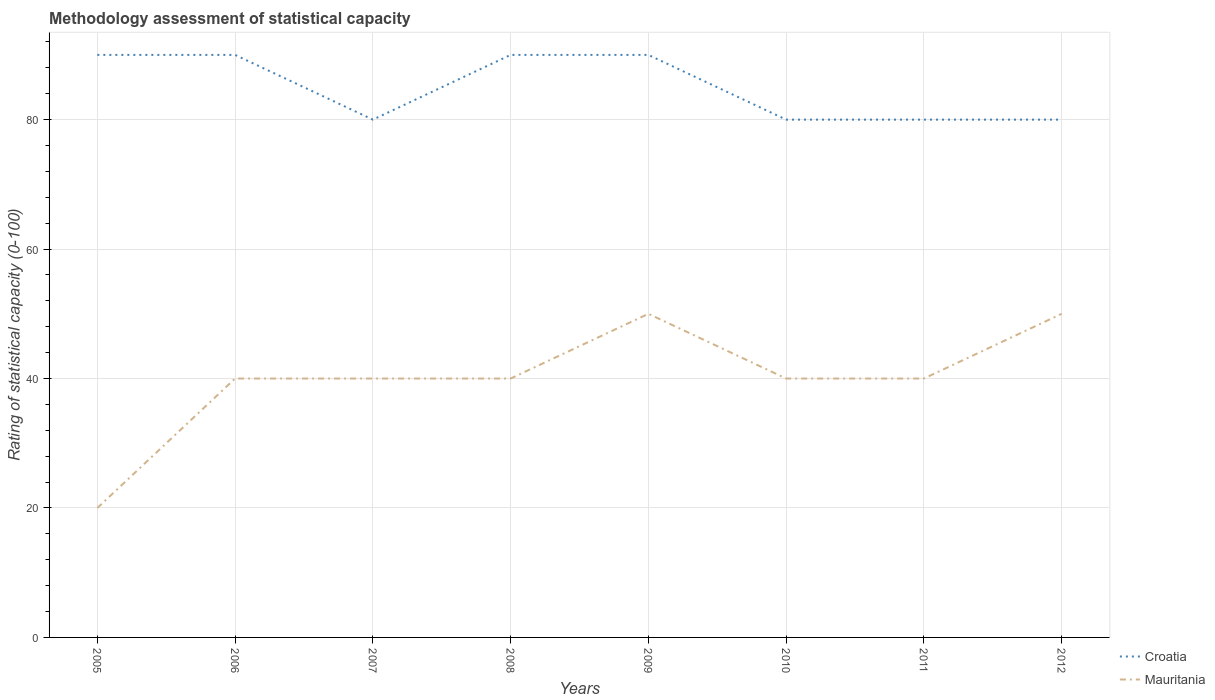How many different coloured lines are there?
Your answer should be compact. 2. Is the number of lines equal to the number of legend labels?
Ensure brevity in your answer.  Yes. Across all years, what is the maximum rating of statistical capacity in Croatia?
Provide a short and direct response. 80. In which year was the rating of statistical capacity in Croatia maximum?
Give a very brief answer. 2007. What is the total rating of statistical capacity in Mauritania in the graph?
Give a very brief answer. 0. What is the difference between the highest and the second highest rating of statistical capacity in Croatia?
Ensure brevity in your answer.  10. How many years are there in the graph?
Provide a short and direct response. 8. What is the difference between two consecutive major ticks on the Y-axis?
Your answer should be very brief. 20. Are the values on the major ticks of Y-axis written in scientific E-notation?
Provide a succinct answer. No. Where does the legend appear in the graph?
Ensure brevity in your answer.  Bottom right. How are the legend labels stacked?
Your answer should be very brief. Vertical. What is the title of the graph?
Provide a succinct answer. Methodology assessment of statistical capacity. Does "Panama" appear as one of the legend labels in the graph?
Your response must be concise. No. What is the label or title of the Y-axis?
Offer a very short reply. Rating of statistical capacity (0-100). What is the Rating of statistical capacity (0-100) of Croatia in 2005?
Offer a very short reply. 90. What is the Rating of statistical capacity (0-100) of Croatia in 2008?
Offer a terse response. 90. What is the Rating of statistical capacity (0-100) of Mauritania in 2008?
Ensure brevity in your answer.  40. What is the Rating of statistical capacity (0-100) of Croatia in 2010?
Ensure brevity in your answer.  80. What is the Rating of statistical capacity (0-100) of Mauritania in 2010?
Provide a short and direct response. 40. What is the Rating of statistical capacity (0-100) in Mauritania in 2011?
Give a very brief answer. 40. What is the Rating of statistical capacity (0-100) of Croatia in 2012?
Provide a succinct answer. 80. What is the Rating of statistical capacity (0-100) of Mauritania in 2012?
Give a very brief answer. 50. Across all years, what is the maximum Rating of statistical capacity (0-100) of Mauritania?
Provide a short and direct response. 50. Across all years, what is the minimum Rating of statistical capacity (0-100) in Croatia?
Keep it short and to the point. 80. Across all years, what is the minimum Rating of statistical capacity (0-100) of Mauritania?
Your response must be concise. 20. What is the total Rating of statistical capacity (0-100) of Croatia in the graph?
Ensure brevity in your answer.  680. What is the total Rating of statistical capacity (0-100) of Mauritania in the graph?
Make the answer very short. 320. What is the difference between the Rating of statistical capacity (0-100) in Mauritania in 2005 and that in 2006?
Keep it short and to the point. -20. What is the difference between the Rating of statistical capacity (0-100) in Croatia in 2005 and that in 2008?
Offer a terse response. 0. What is the difference between the Rating of statistical capacity (0-100) of Mauritania in 2005 and that in 2010?
Make the answer very short. -20. What is the difference between the Rating of statistical capacity (0-100) of Croatia in 2005 and that in 2011?
Your response must be concise. 10. What is the difference between the Rating of statistical capacity (0-100) of Mauritania in 2005 and that in 2011?
Provide a short and direct response. -20. What is the difference between the Rating of statistical capacity (0-100) in Mauritania in 2005 and that in 2012?
Offer a very short reply. -30. What is the difference between the Rating of statistical capacity (0-100) in Croatia in 2006 and that in 2009?
Provide a short and direct response. 0. What is the difference between the Rating of statistical capacity (0-100) of Croatia in 2006 and that in 2010?
Your response must be concise. 10. What is the difference between the Rating of statistical capacity (0-100) of Croatia in 2006 and that in 2011?
Give a very brief answer. 10. What is the difference between the Rating of statistical capacity (0-100) of Croatia in 2007 and that in 2010?
Your answer should be very brief. 0. What is the difference between the Rating of statistical capacity (0-100) in Mauritania in 2007 and that in 2010?
Offer a terse response. 0. What is the difference between the Rating of statistical capacity (0-100) of Mauritania in 2007 and that in 2011?
Keep it short and to the point. 0. What is the difference between the Rating of statistical capacity (0-100) of Croatia in 2007 and that in 2012?
Give a very brief answer. 0. What is the difference between the Rating of statistical capacity (0-100) of Croatia in 2008 and that in 2009?
Offer a very short reply. 0. What is the difference between the Rating of statistical capacity (0-100) of Mauritania in 2008 and that in 2009?
Keep it short and to the point. -10. What is the difference between the Rating of statistical capacity (0-100) of Croatia in 2008 and that in 2010?
Your response must be concise. 10. What is the difference between the Rating of statistical capacity (0-100) in Mauritania in 2008 and that in 2010?
Provide a short and direct response. 0. What is the difference between the Rating of statistical capacity (0-100) of Croatia in 2009 and that in 2010?
Offer a very short reply. 10. What is the difference between the Rating of statistical capacity (0-100) in Mauritania in 2009 and that in 2011?
Provide a short and direct response. 10. What is the difference between the Rating of statistical capacity (0-100) of Croatia in 2009 and that in 2012?
Ensure brevity in your answer.  10. What is the difference between the Rating of statistical capacity (0-100) in Mauritania in 2009 and that in 2012?
Give a very brief answer. 0. What is the difference between the Rating of statistical capacity (0-100) in Croatia in 2010 and that in 2011?
Your answer should be very brief. 0. What is the difference between the Rating of statistical capacity (0-100) in Mauritania in 2010 and that in 2011?
Give a very brief answer. 0. What is the difference between the Rating of statistical capacity (0-100) in Croatia in 2010 and that in 2012?
Your answer should be compact. 0. What is the difference between the Rating of statistical capacity (0-100) of Croatia in 2005 and the Rating of statistical capacity (0-100) of Mauritania in 2011?
Offer a very short reply. 50. What is the difference between the Rating of statistical capacity (0-100) of Croatia in 2006 and the Rating of statistical capacity (0-100) of Mauritania in 2007?
Offer a very short reply. 50. What is the difference between the Rating of statistical capacity (0-100) in Croatia in 2006 and the Rating of statistical capacity (0-100) in Mauritania in 2008?
Ensure brevity in your answer.  50. What is the difference between the Rating of statistical capacity (0-100) of Croatia in 2008 and the Rating of statistical capacity (0-100) of Mauritania in 2009?
Your response must be concise. 40. What is the difference between the Rating of statistical capacity (0-100) in Croatia in 2008 and the Rating of statistical capacity (0-100) in Mauritania in 2011?
Provide a short and direct response. 50. What is the difference between the Rating of statistical capacity (0-100) of Croatia in 2008 and the Rating of statistical capacity (0-100) of Mauritania in 2012?
Your response must be concise. 40. What is the difference between the Rating of statistical capacity (0-100) in Croatia in 2009 and the Rating of statistical capacity (0-100) in Mauritania in 2010?
Ensure brevity in your answer.  50. What is the difference between the Rating of statistical capacity (0-100) of Croatia in 2010 and the Rating of statistical capacity (0-100) of Mauritania in 2012?
Ensure brevity in your answer.  30. What is the difference between the Rating of statistical capacity (0-100) of Croatia in 2011 and the Rating of statistical capacity (0-100) of Mauritania in 2012?
Offer a terse response. 30. In the year 2005, what is the difference between the Rating of statistical capacity (0-100) in Croatia and Rating of statistical capacity (0-100) in Mauritania?
Give a very brief answer. 70. In the year 2007, what is the difference between the Rating of statistical capacity (0-100) of Croatia and Rating of statistical capacity (0-100) of Mauritania?
Your answer should be compact. 40. In the year 2010, what is the difference between the Rating of statistical capacity (0-100) in Croatia and Rating of statistical capacity (0-100) in Mauritania?
Offer a terse response. 40. In the year 2011, what is the difference between the Rating of statistical capacity (0-100) in Croatia and Rating of statistical capacity (0-100) in Mauritania?
Your answer should be compact. 40. In the year 2012, what is the difference between the Rating of statistical capacity (0-100) of Croatia and Rating of statistical capacity (0-100) of Mauritania?
Provide a succinct answer. 30. What is the ratio of the Rating of statistical capacity (0-100) in Croatia in 2005 to that in 2007?
Your answer should be very brief. 1.12. What is the ratio of the Rating of statistical capacity (0-100) of Mauritania in 2005 to that in 2007?
Your answer should be compact. 0.5. What is the ratio of the Rating of statistical capacity (0-100) in Croatia in 2005 to that in 2008?
Provide a succinct answer. 1. What is the ratio of the Rating of statistical capacity (0-100) of Mauritania in 2005 to that in 2009?
Offer a very short reply. 0.4. What is the ratio of the Rating of statistical capacity (0-100) of Croatia in 2005 to that in 2012?
Provide a short and direct response. 1.12. What is the ratio of the Rating of statistical capacity (0-100) of Mauritania in 2005 to that in 2012?
Provide a succinct answer. 0.4. What is the ratio of the Rating of statistical capacity (0-100) in Croatia in 2006 to that in 2007?
Provide a short and direct response. 1.12. What is the ratio of the Rating of statistical capacity (0-100) of Mauritania in 2006 to that in 2007?
Your answer should be very brief. 1. What is the ratio of the Rating of statistical capacity (0-100) of Mauritania in 2006 to that in 2008?
Make the answer very short. 1. What is the ratio of the Rating of statistical capacity (0-100) of Mauritania in 2006 to that in 2009?
Make the answer very short. 0.8. What is the ratio of the Rating of statistical capacity (0-100) of Croatia in 2006 to that in 2010?
Offer a terse response. 1.12. What is the ratio of the Rating of statistical capacity (0-100) in Croatia in 2006 to that in 2011?
Provide a succinct answer. 1.12. What is the ratio of the Rating of statistical capacity (0-100) in Mauritania in 2006 to that in 2012?
Offer a very short reply. 0.8. What is the ratio of the Rating of statistical capacity (0-100) of Mauritania in 2007 to that in 2008?
Keep it short and to the point. 1. What is the ratio of the Rating of statistical capacity (0-100) of Croatia in 2007 to that in 2009?
Keep it short and to the point. 0.89. What is the ratio of the Rating of statistical capacity (0-100) of Mauritania in 2007 to that in 2009?
Ensure brevity in your answer.  0.8. What is the ratio of the Rating of statistical capacity (0-100) of Croatia in 2007 to that in 2010?
Give a very brief answer. 1. What is the ratio of the Rating of statistical capacity (0-100) in Mauritania in 2007 to that in 2010?
Offer a terse response. 1. What is the ratio of the Rating of statistical capacity (0-100) in Mauritania in 2007 to that in 2012?
Provide a short and direct response. 0.8. What is the ratio of the Rating of statistical capacity (0-100) in Mauritania in 2008 to that in 2010?
Your response must be concise. 1. What is the ratio of the Rating of statistical capacity (0-100) in Croatia in 2008 to that in 2011?
Keep it short and to the point. 1.12. What is the ratio of the Rating of statistical capacity (0-100) of Mauritania in 2008 to that in 2011?
Provide a short and direct response. 1. What is the ratio of the Rating of statistical capacity (0-100) of Croatia in 2008 to that in 2012?
Keep it short and to the point. 1.12. What is the ratio of the Rating of statistical capacity (0-100) in Mauritania in 2008 to that in 2012?
Offer a very short reply. 0.8. What is the ratio of the Rating of statistical capacity (0-100) in Croatia in 2009 to that in 2010?
Keep it short and to the point. 1.12. What is the ratio of the Rating of statistical capacity (0-100) in Croatia in 2009 to that in 2011?
Ensure brevity in your answer.  1.12. What is the ratio of the Rating of statistical capacity (0-100) of Croatia in 2009 to that in 2012?
Ensure brevity in your answer.  1.12. What is the ratio of the Rating of statistical capacity (0-100) of Mauritania in 2009 to that in 2012?
Ensure brevity in your answer.  1. What is the ratio of the Rating of statistical capacity (0-100) of Croatia in 2010 to that in 2011?
Give a very brief answer. 1. What is the ratio of the Rating of statistical capacity (0-100) of Croatia in 2010 to that in 2012?
Give a very brief answer. 1. What is the ratio of the Rating of statistical capacity (0-100) in Mauritania in 2010 to that in 2012?
Make the answer very short. 0.8. What is the ratio of the Rating of statistical capacity (0-100) in Croatia in 2011 to that in 2012?
Offer a terse response. 1. What is the ratio of the Rating of statistical capacity (0-100) in Mauritania in 2011 to that in 2012?
Your answer should be very brief. 0.8. What is the difference between the highest and the second highest Rating of statistical capacity (0-100) of Croatia?
Make the answer very short. 0. What is the difference between the highest and the second highest Rating of statistical capacity (0-100) of Mauritania?
Your answer should be compact. 0. What is the difference between the highest and the lowest Rating of statistical capacity (0-100) in Mauritania?
Give a very brief answer. 30. 